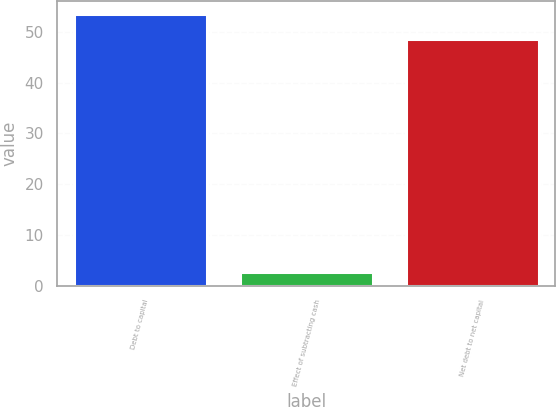Convert chart. <chart><loc_0><loc_0><loc_500><loc_500><bar_chart><fcel>Debt to capital<fcel>Effect of subtracting cash<fcel>Net debt to net capital<nl><fcel>53.46<fcel>2.6<fcel>48.6<nl></chart> 